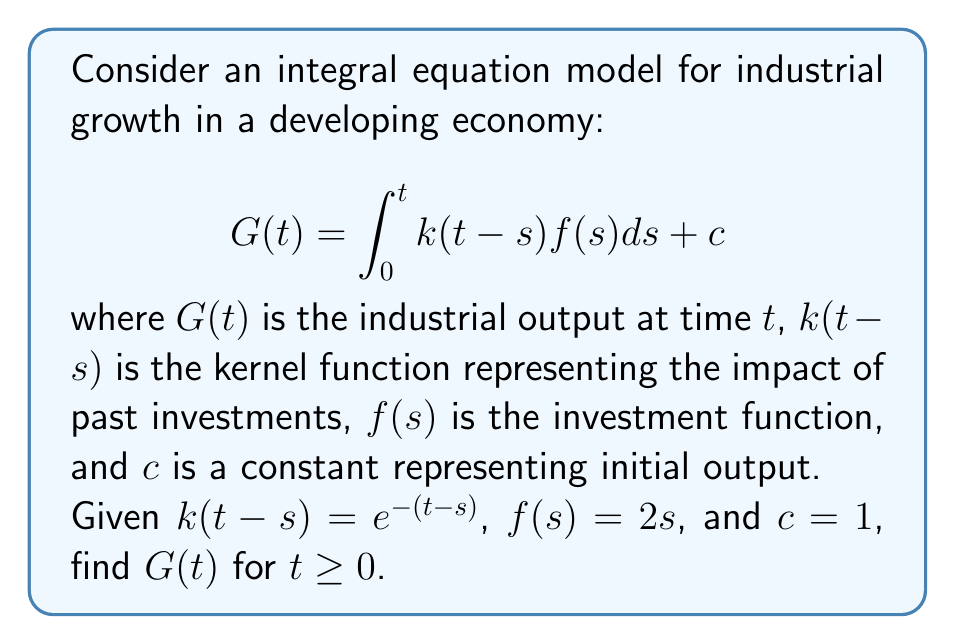Teach me how to tackle this problem. To solve this integral equation, we'll follow these steps:

1) First, substitute the given functions into the integral equation:
   $$G(t) = \int_0^t e^{-(t-s)}(2s)ds + 1$$

2) Simplify the integrand:
   $$G(t) = \int_0^t 2se^{-(t-s)}ds + 1$$

3) Use integration by parts. Let $u = 2s$ and $dv = e^{-(t-s)}ds$:
   $$G(t) = [-2se^{-(t-s)}]_0^t + \int_0^t 2e^{-(t-s)}ds + 1$$

4) Evaluate the first term:
   $$G(t) = -2te^{-(t-t)} + 2\cdot0\cdot e^{-(t-0)} + \int_0^t 2e^{-(t-s)}ds + 1$$
   $$G(t) = -2t + \int_0^t 2e^{-(t-s)}ds + 1$$

5) Solve the remaining integral:
   $$\int_0^t 2e^{-(t-s)}ds = 2e^{-t}\int_0^t e^s ds = 2e^{-t}[e^s]_0^t = 2e^{-t}(e^t - 1) = 2 - 2e^{-t}$$

6) Substitute this result back into the equation:
   $$G(t) = -2t + (2 - 2e^{-t}) + 1$$

7) Simplify:
   $$G(t) = -2t + 3 - 2e^{-t}$$
Answer: $G(t) = -2t + 3 - 2e^{-t}$ 